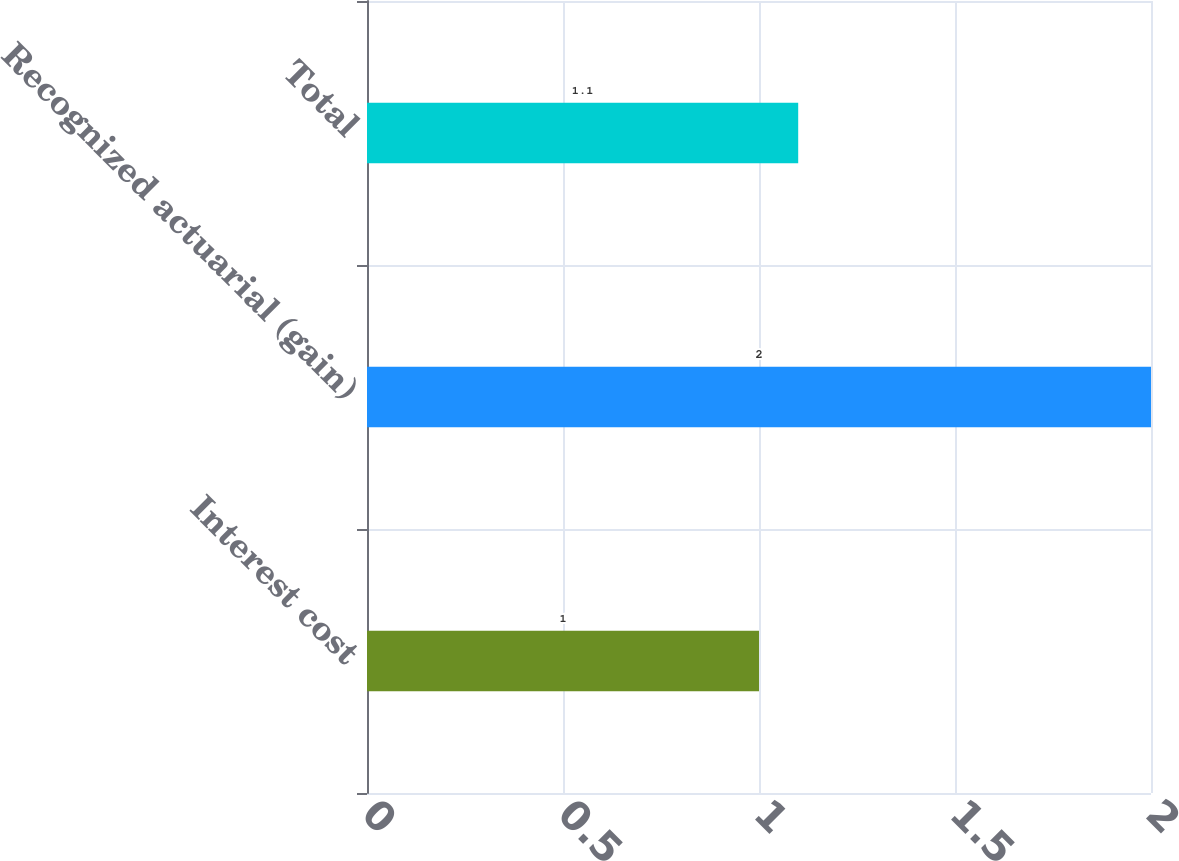<chart> <loc_0><loc_0><loc_500><loc_500><bar_chart><fcel>Interest cost<fcel>Recognized actuarial (gain)<fcel>Total<nl><fcel>1<fcel>2<fcel>1.1<nl></chart> 